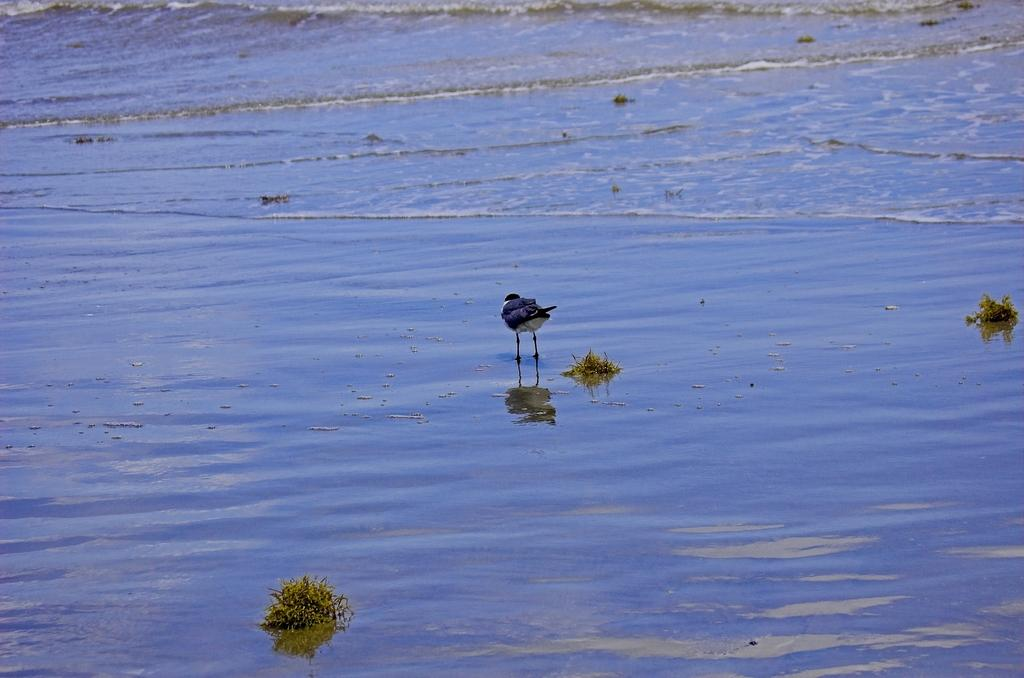What is at the bottom of the image? There is water at the bottom of the image. What can be seen in the water? There is a bird in the water. What vegetable is the bird eating in the image? There is no vegetable present in the image, as it only features a bird in the water. 